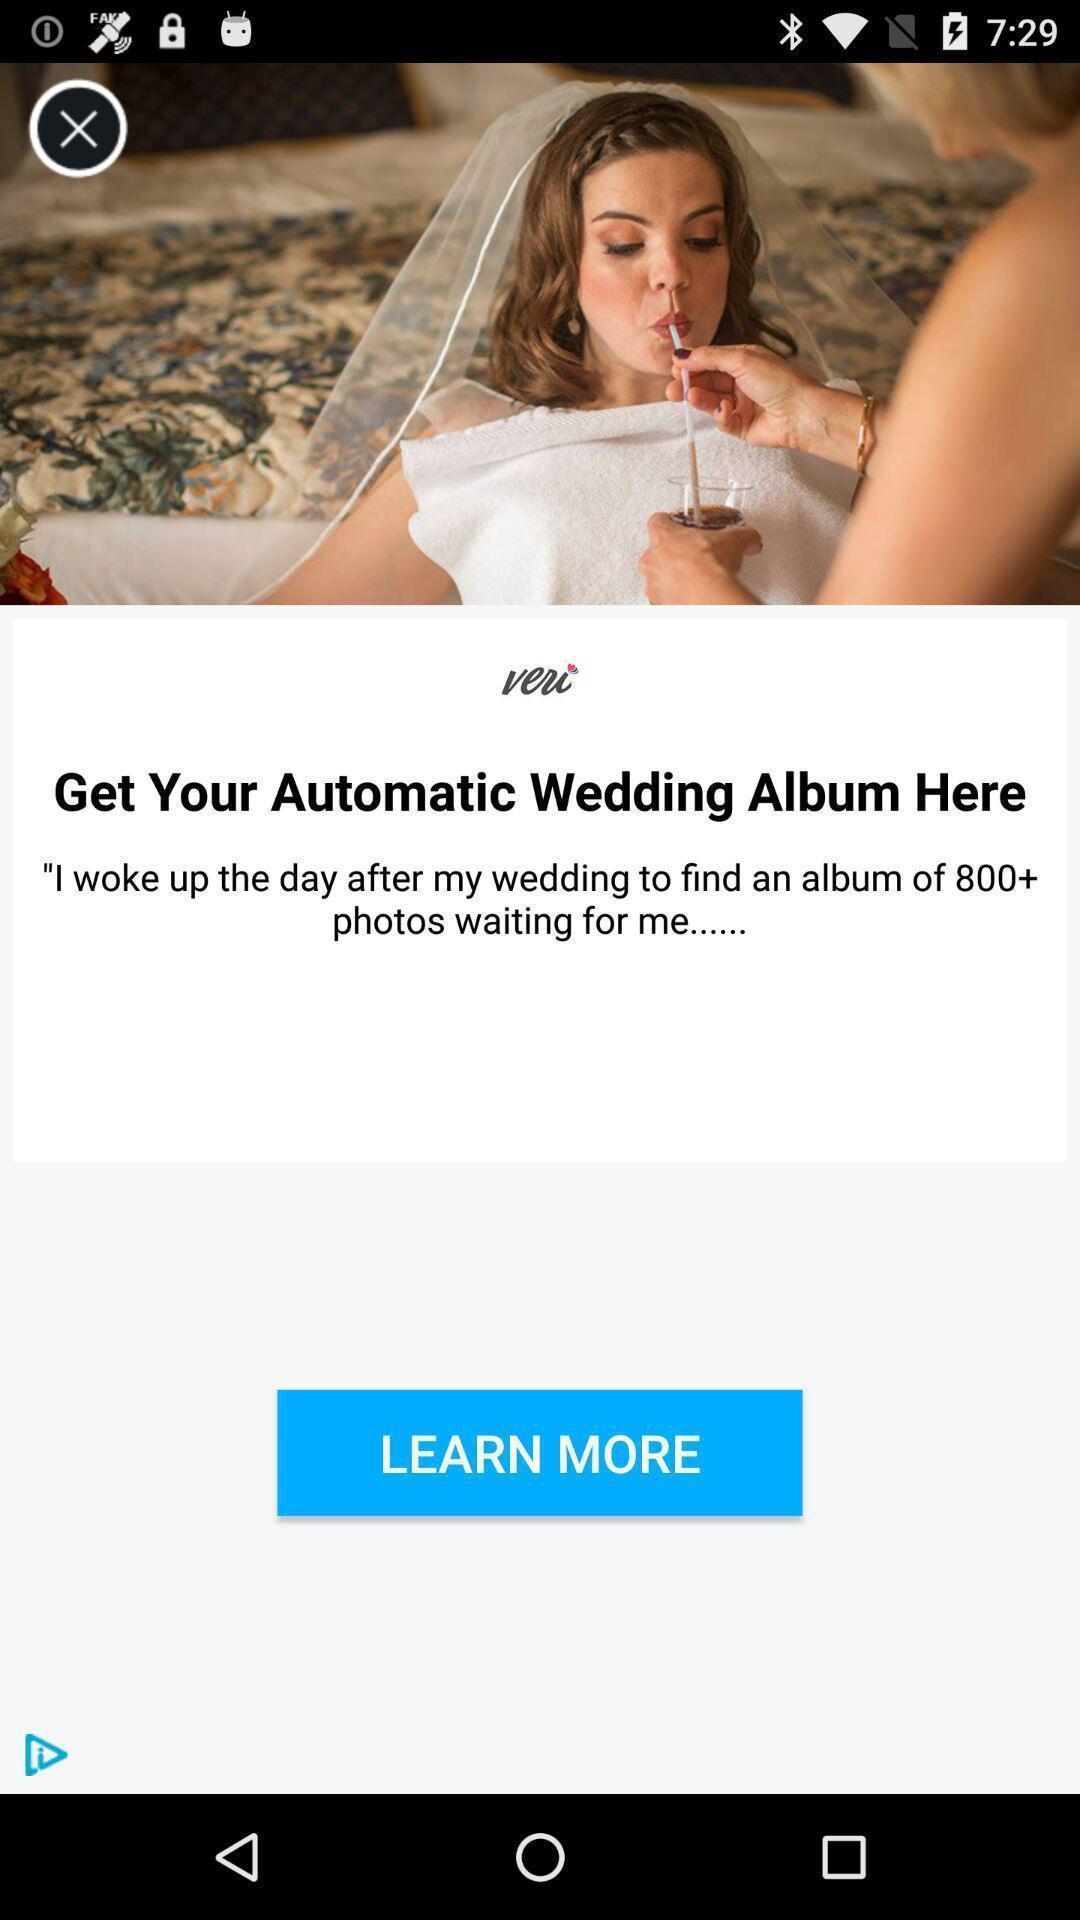Provide a textual representation of this image. Pop up of wedding album application. 